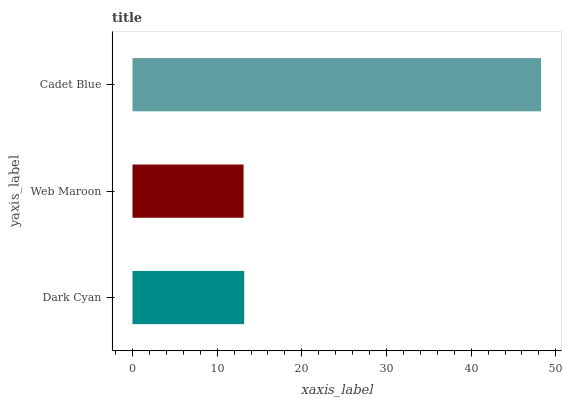Is Web Maroon the minimum?
Answer yes or no. Yes. Is Cadet Blue the maximum?
Answer yes or no. Yes. Is Cadet Blue the minimum?
Answer yes or no. No. Is Web Maroon the maximum?
Answer yes or no. No. Is Cadet Blue greater than Web Maroon?
Answer yes or no. Yes. Is Web Maroon less than Cadet Blue?
Answer yes or no. Yes. Is Web Maroon greater than Cadet Blue?
Answer yes or no. No. Is Cadet Blue less than Web Maroon?
Answer yes or no. No. Is Dark Cyan the high median?
Answer yes or no. Yes. Is Dark Cyan the low median?
Answer yes or no. Yes. Is Web Maroon the high median?
Answer yes or no. No. Is Web Maroon the low median?
Answer yes or no. No. 